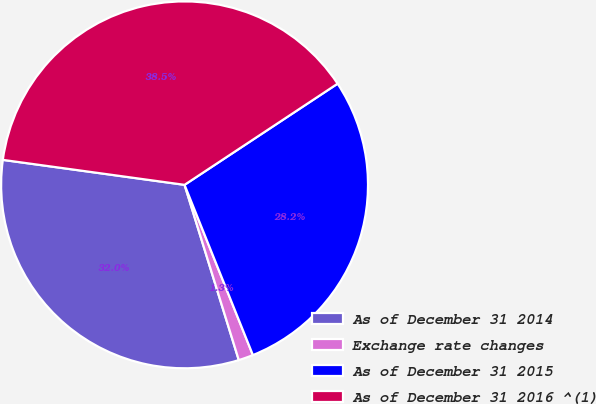<chart> <loc_0><loc_0><loc_500><loc_500><pie_chart><fcel>As of December 31 2014<fcel>Exchange rate changes<fcel>As of December 31 2015<fcel>As of December 31 2016 ^(1)<nl><fcel>31.95%<fcel>1.3%<fcel>28.22%<fcel>38.53%<nl></chart> 